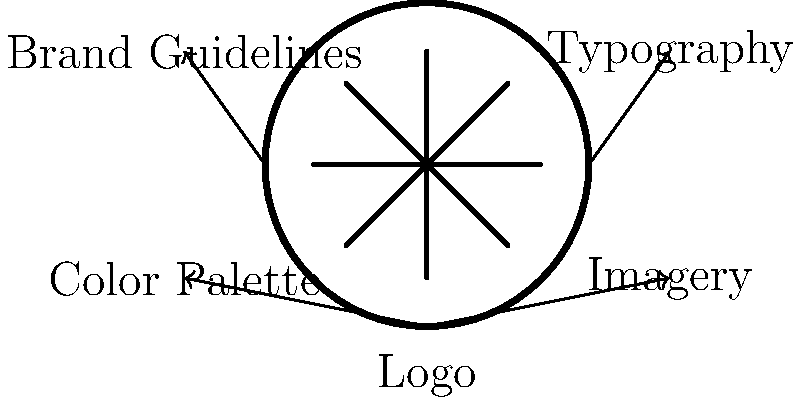As a graphic designer for esports teams, you're tasked with creating a cohesive brand identity system for a new organization. Which element in the diagram serves as the central foundation for the entire brand identity, and how does it influence the other components? To answer this question, let's analyze the diagram and understand the relationships between the elements:

1. The central circle in the diagram represents the Logo, which is the core element of the brand identity system.

2. The Logo is connected to four other elements: Typography, Color Palette, Imagery, and Brand Guidelines.

3. These connections indicate that the Logo influences and informs the development of the other components:

   a. Typography: The logo's style can guide the choice of fonts and text treatments used across the brand.
   b. Color Palette: The colors used in the logo often form the basis of the brand's color scheme.
   c. Imagery: The logo's design elements and style can inspire the visual language used in other brand imagery.
   d. Brand Guidelines: The logo's usage rules and applications are a crucial part of the overall brand guidelines.

4. The Logo serves as the central foundation because:
   - It's the most recognizable element of the brand
   - It encapsulates the brand's essence and values
   - It sets the visual tone for all other brand elements

5. By influencing the other components, the Logo ensures consistency and coherence across all aspects of the brand identity system, which is crucial for building a strong and memorable esports brand.

Therefore, the Logo is the central foundation of the brand identity system, influencing all other elements to create a cohesive visual identity for the esports organization.
Answer: Logo 